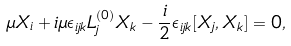<formula> <loc_0><loc_0><loc_500><loc_500>\mu X _ { i } + i \mu \epsilon _ { i j k } L _ { j } ^ { ( 0 ) } X _ { k } - \frac { i } { 2 } \epsilon _ { i j k } [ X _ { j } , X _ { k } ] = 0 ,</formula> 